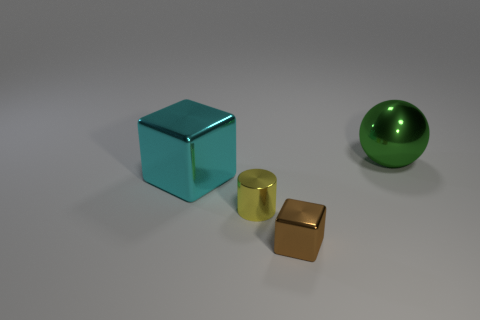Is there any other thing that is the same shape as the green object?
Provide a succinct answer. No. What number of yellow metal objects are on the left side of the large thing left of the big shiny sphere?
Provide a short and direct response. 0. Does the big thing left of the large green thing have the same material as the large green sphere?
Give a very brief answer. Yes. Does the block in front of the metal cylinder have the same material as the small yellow thing that is in front of the large metallic block?
Ensure brevity in your answer.  Yes. Are there more tiny yellow things that are to the right of the green thing than cyan objects?
Ensure brevity in your answer.  No. The metallic block in front of the big cyan metallic thing that is behind the brown metallic cube is what color?
Provide a succinct answer. Brown. There is a metallic object that is the same size as the metallic sphere; what is its shape?
Make the answer very short. Cube. Is the number of small shiny cylinders that are on the left side of the yellow metal cylinder the same as the number of large yellow matte cubes?
Offer a terse response. Yes. What is the large thing that is in front of the big thing that is to the right of the tiny shiny thing on the right side of the yellow metallic object made of?
Offer a terse response. Metal. What is the shape of the cyan thing that is made of the same material as the yellow cylinder?
Give a very brief answer. Cube. 